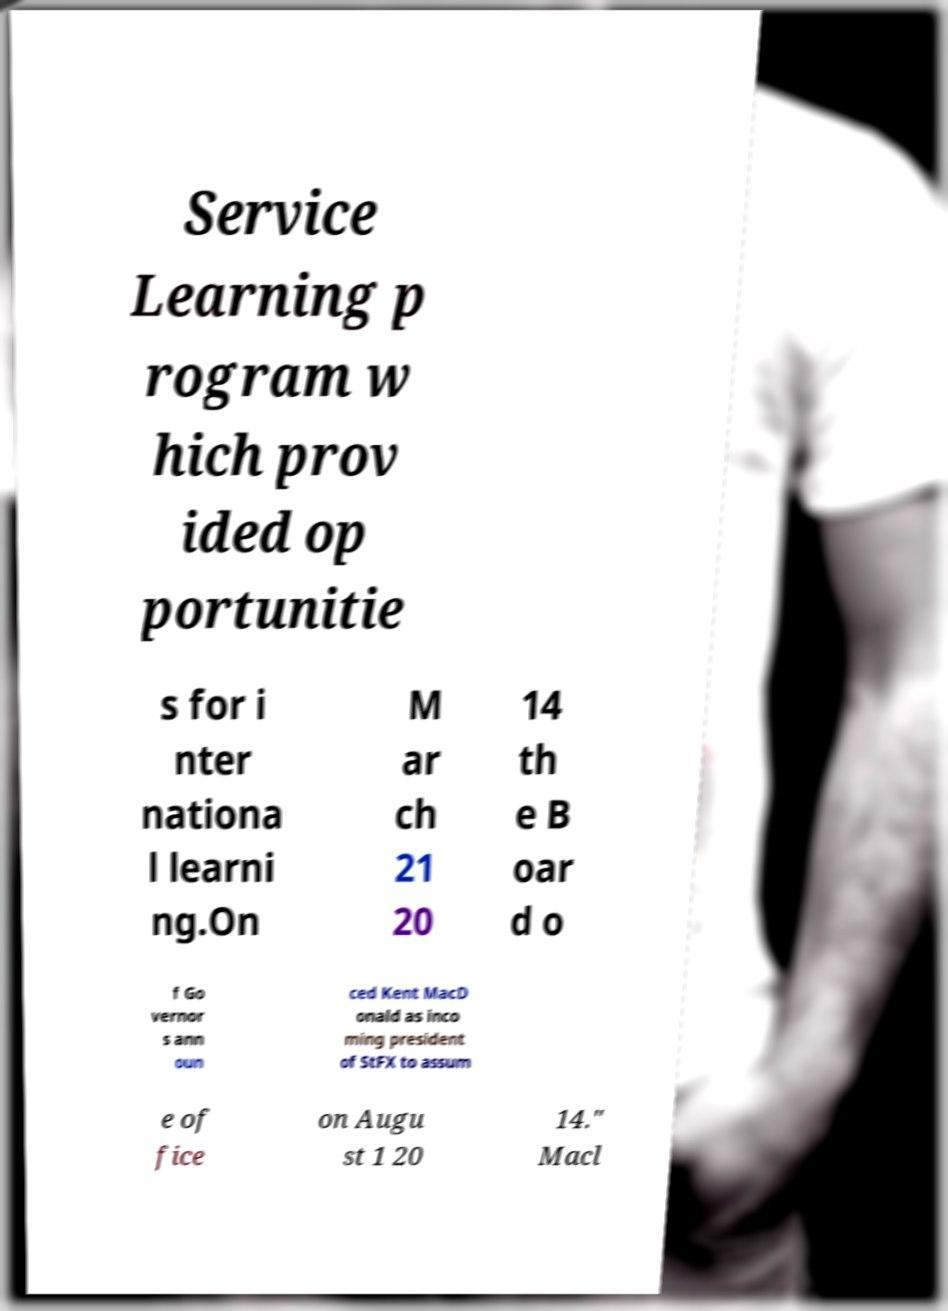Please identify and transcribe the text found in this image. Service Learning p rogram w hich prov ided op portunitie s for i nter nationa l learni ng.On M ar ch 21 20 14 th e B oar d o f Go vernor s ann oun ced Kent MacD onald as inco ming president of StFX to assum e of fice on Augu st 1 20 14." Macl 